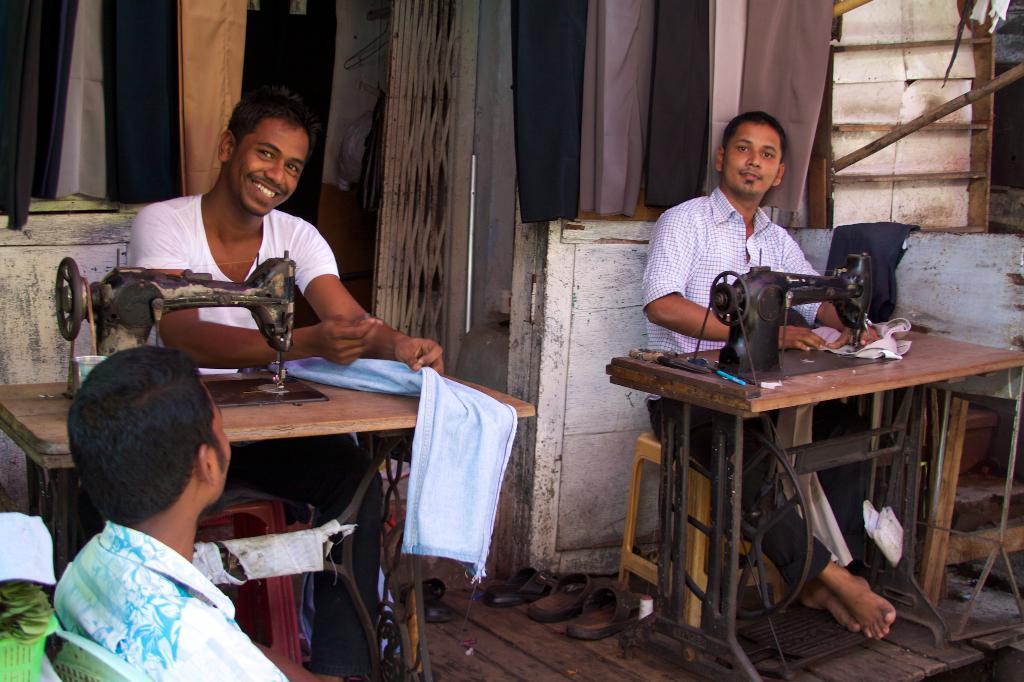Can you describe this image briefly? In this image I can see three men where two of them are sitting in front of sewing machines. 